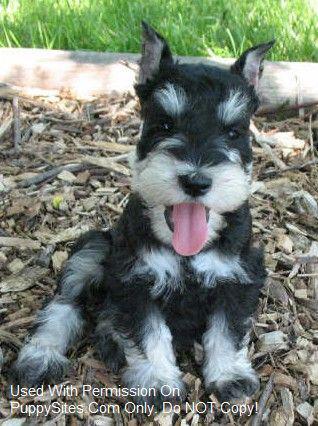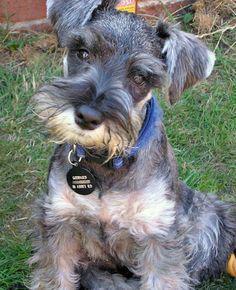The first image is the image on the left, the second image is the image on the right. Considering the images on both sides, is "An image shows a frontward-facing schnauzer wearing a collar." valid? Answer yes or no. Yes. The first image is the image on the left, the second image is the image on the right. For the images shown, is this caption "Two dogs are sitting down and looking at the camera." true? Answer yes or no. Yes. 